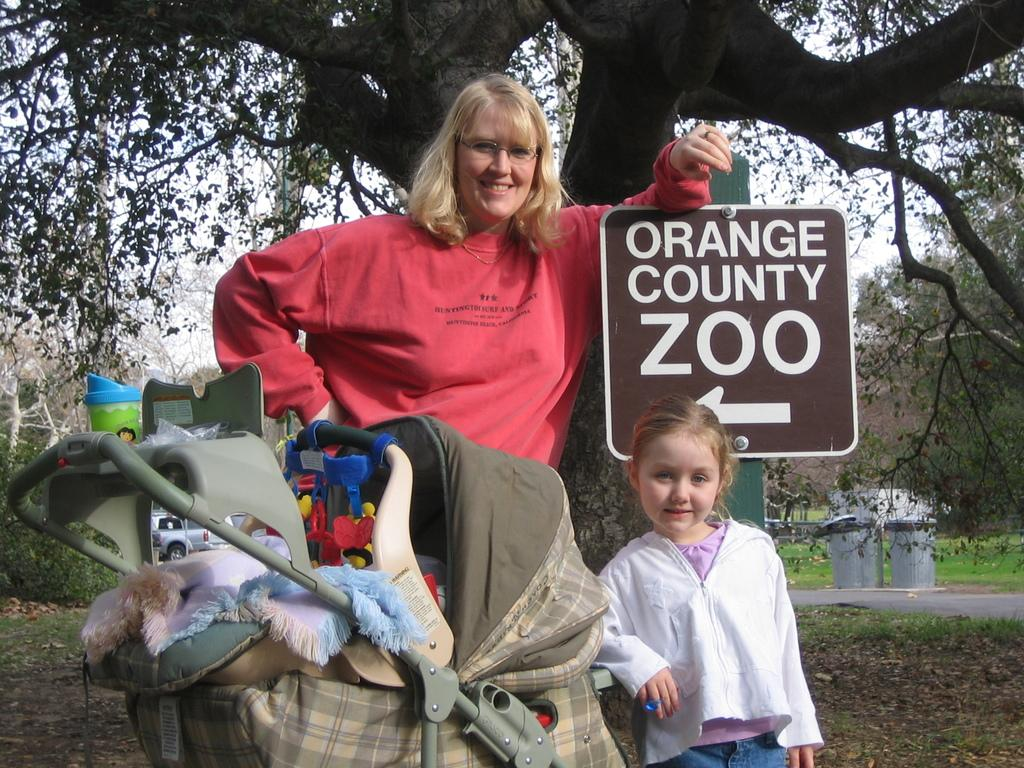Who is present in the image? There is a woman and a child in the image. Where are they standing in the image? They are standing under a tree. What object can be seen in the image that might be used for carrying items? There is a bag in the image. What type of signage is visible in the image? There is a signboard in the image. What part of the tree is visible in the image? The bark of the tree is visible in the image. What type of receptacles are present in the image for disposing of waste? There are dustbins in the image. What type of vegetation is present in the image? Grass is present in the image. What part of the natural environment is visible in the image? The sky is visible in the image. What type of disgusting creature can be seen crawling on the woman's pocket in the image? There is no creature visible on the woman's pocket in the image. How does the child push the tree in the image? The child is not pushing the tree in the image; they are standing under it. 